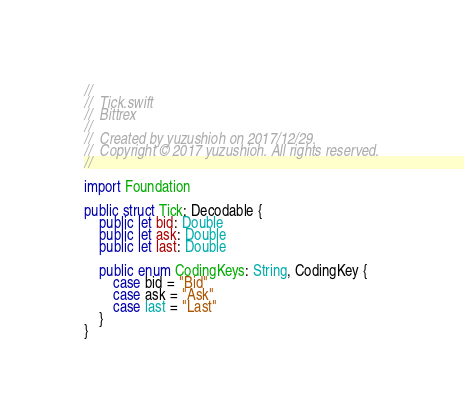<code> <loc_0><loc_0><loc_500><loc_500><_Swift_>//
//  Tick.swift
//  Bittrex
//
//  Created by yuzushioh on 2017/12/29.
//  Copyright © 2017 yuzushioh. All rights reserved.
//

import Foundation

public struct Tick: Decodable {
    public let bid: Double
    public let ask: Double
    public let last: Double
    
    public enum CodingKeys: String, CodingKey {
        case bid = "Bid"
        case ask = "Ask"
        case last = "Last"
    }
}
</code> 